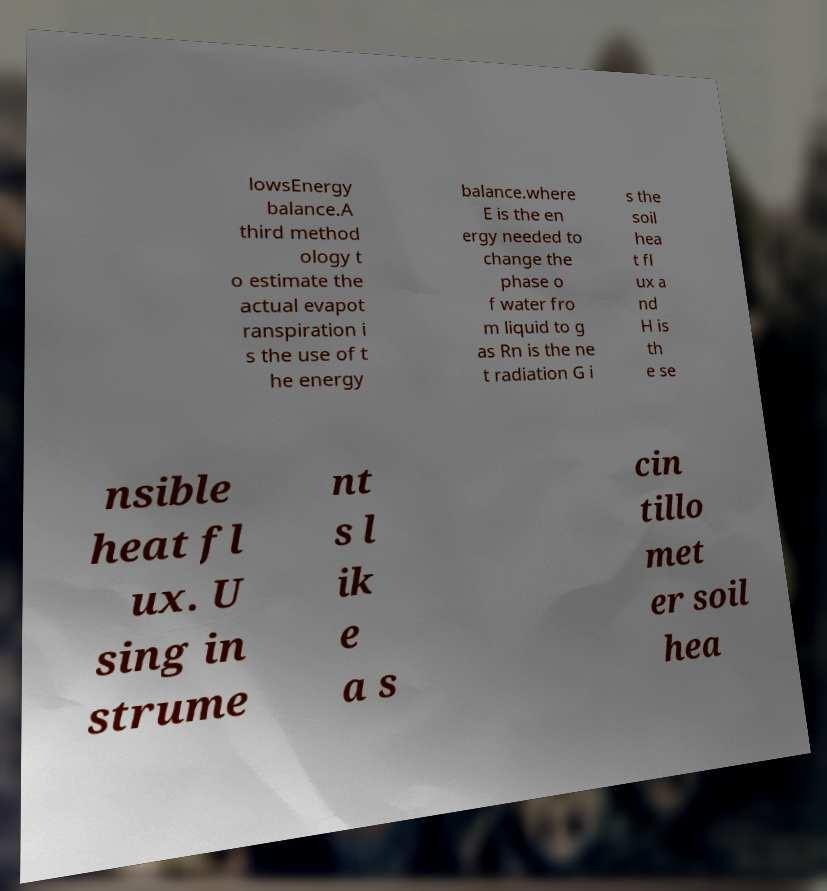Can you accurately transcribe the text from the provided image for me? lowsEnergy balance.A third method ology t o estimate the actual evapot ranspiration i s the use of t he energy balance.where E is the en ergy needed to change the phase o f water fro m liquid to g as Rn is the ne t radiation G i s the soil hea t fl ux a nd H is th e se nsible heat fl ux. U sing in strume nt s l ik e a s cin tillo met er soil hea 